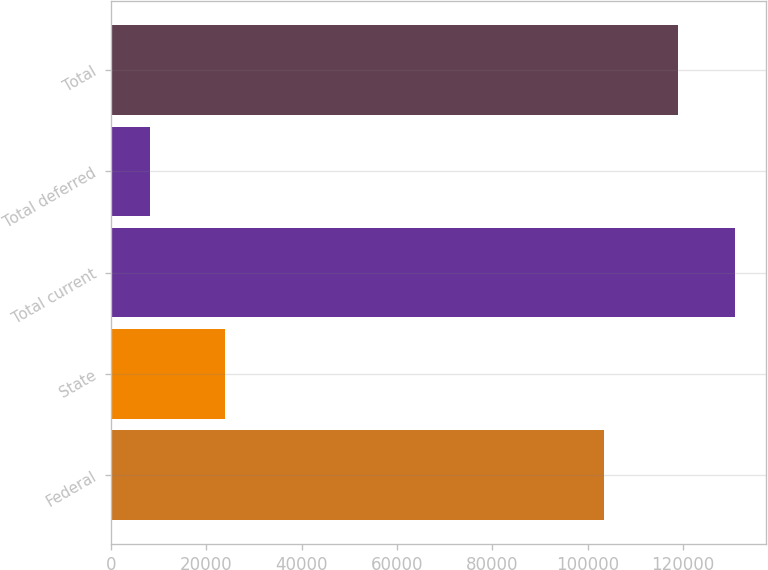Convert chart. <chart><loc_0><loc_0><loc_500><loc_500><bar_chart><fcel>Federal<fcel>State<fcel>Total current<fcel>Total deferred<fcel>Total<nl><fcel>103344<fcel>23939<fcel>130901<fcel>8282<fcel>119001<nl></chart> 